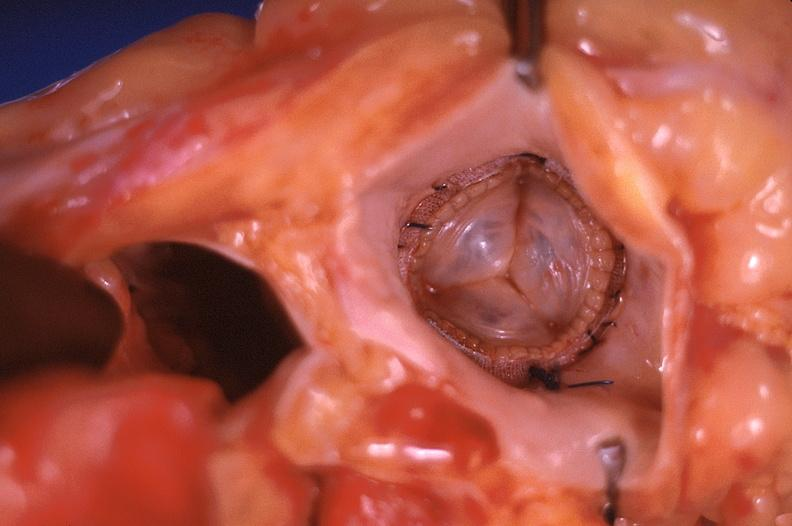where is this?
Answer the question using a single word or phrase. Heart 